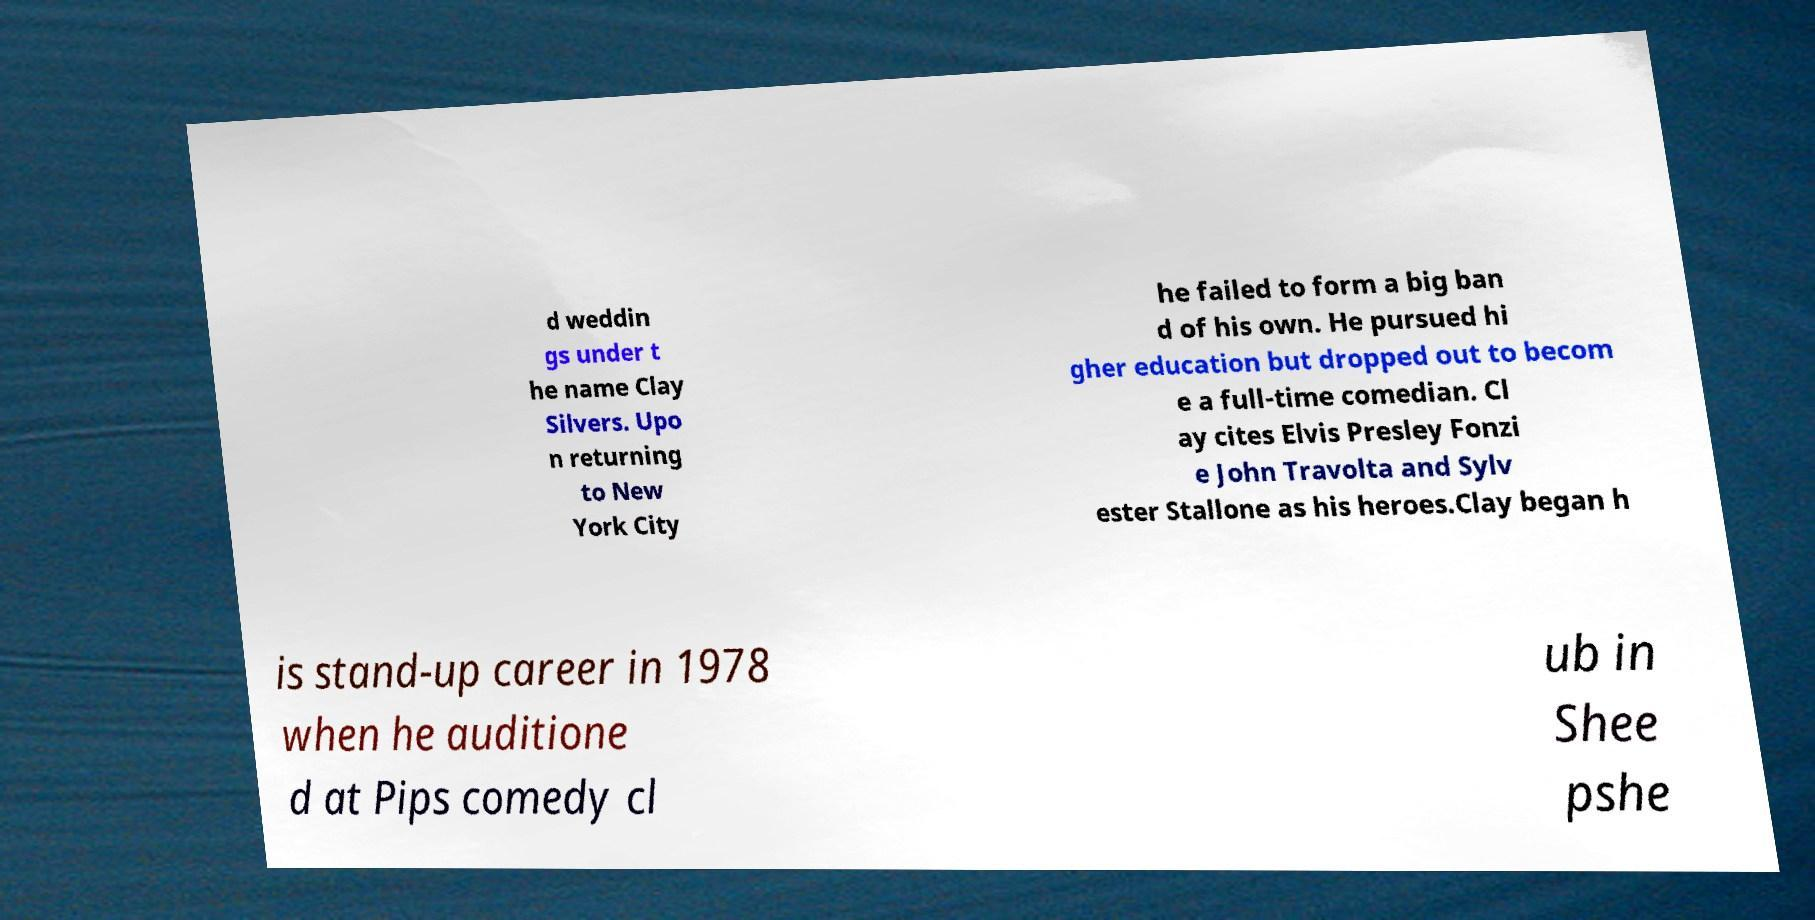Please read and relay the text visible in this image. What does it say? d weddin gs under t he name Clay Silvers. Upo n returning to New York City he failed to form a big ban d of his own. He pursued hi gher education but dropped out to becom e a full-time comedian. Cl ay cites Elvis Presley Fonzi e John Travolta and Sylv ester Stallone as his heroes.Clay began h is stand-up career in 1978 when he auditione d at Pips comedy cl ub in Shee pshe 